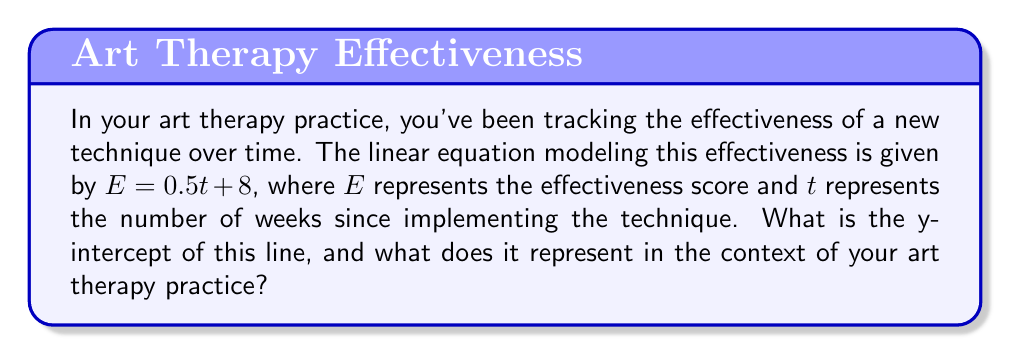Can you solve this math problem? To find the y-intercept of the given linear equation, we need to follow these steps:

1) The general form of a linear equation is $y = mx + b$, where $b$ is the y-intercept.

2) In our equation, $E = 0.5t + 8$, we can identify that:
   $E$ corresponds to $y$
   $t$ corresponds to $x$
   $0.5$ is the slope ($m$)
   $8$ is the y-intercept ($b$)

3) Therefore, the y-intercept is 8.

In the context of art therapy, the y-intercept represents the initial effectiveness score of the technique when it was first implemented (at week 0). This means that before any time had passed (t = 0), the effectiveness score of the technique was already at 8.

To verify this mathematically:
When $t = 0$, $E = 0.5(0) + 8 = 8$

This initial score could represent a baseline effectiveness due to factors such as the therapist's existing skills, the inherent appeal of the new technique to clients, or immediate positive responses from clients upon introduction of the technique.
Answer: 8; initial effectiveness score at implementation 